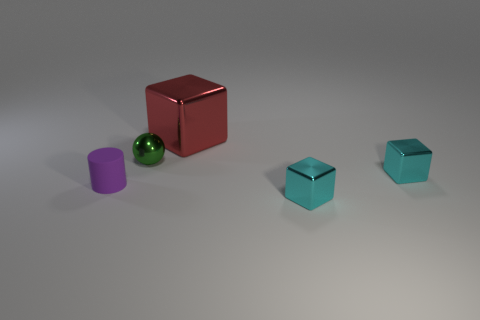Are there more small shiny spheres that are behind the tiny purple cylinder than purple matte cylinders behind the tiny metallic sphere? No, there are not more small shiny spheres behind the tiny purple cylinder than purple matte cylinders behind the tiny metallic sphere. In fact, there is only one small shiny sphere in the image and it is not behind the tiny purple cylinder, but beside it. There are also no purple matte cylinders at all in this image. 